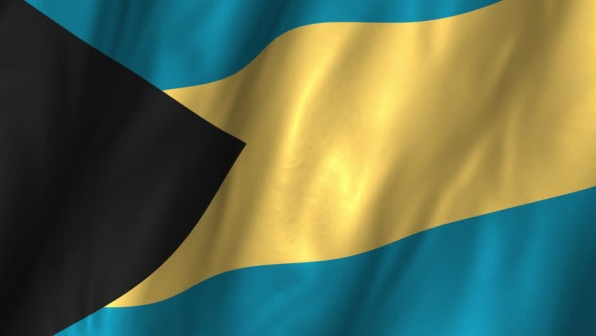Imagine the flag is waving to celebrate a significant national event. What could that event be, and how might people be celebrating? The flag might be waving proudly in celebration of Bahamian Independence Day, commemorated on July 10th each year. On this day, citizens across the islands gather for parades featuring vibrant displays of Bahamian culture. People wear traditional attire, made from colorful fabrics. Streets fill with the sounds of drums, horns, and whistles as the Junkanoo performers energize the crowd. Families and friends come together for feasts featuring local delicacies like conch salad and Bahama Mama cocktails. The day culminates in spectacular fireworks lighting up the night sky, reflecting off the crystal-clear waters, symbolizing the joy and pride of a free and independent Bahamas. 